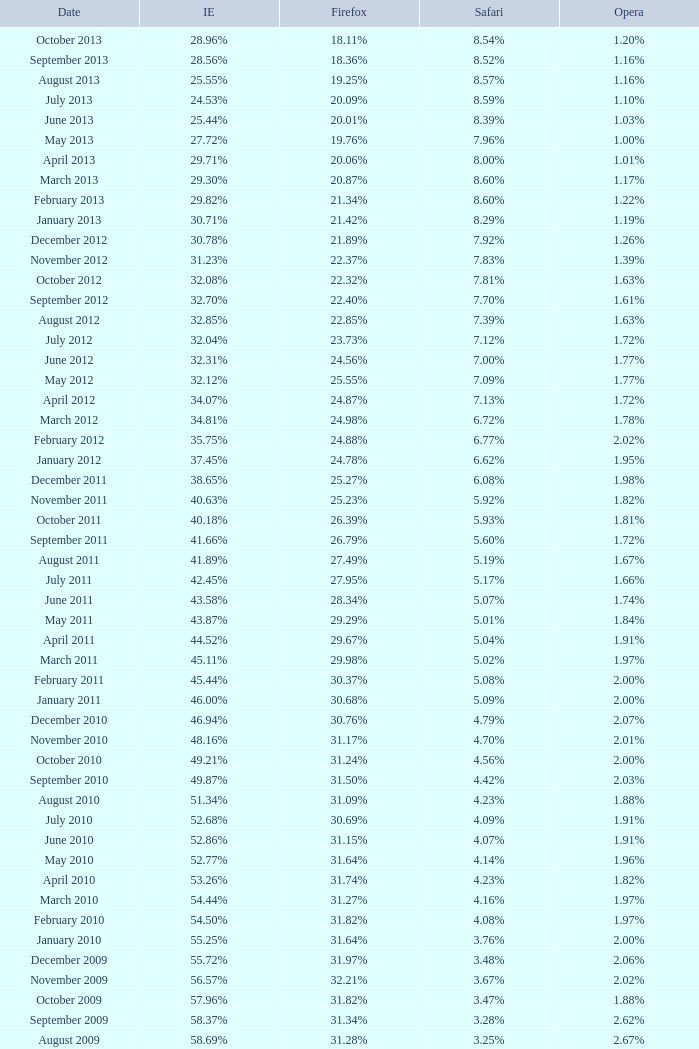What percentage of browsers were using Opera in October 2010? 2.00%. 